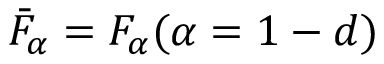<formula> <loc_0><loc_0><loc_500><loc_500>\bar { F } _ { \alpha } = F _ { \alpha } ( \alpha = 1 - d )</formula> 